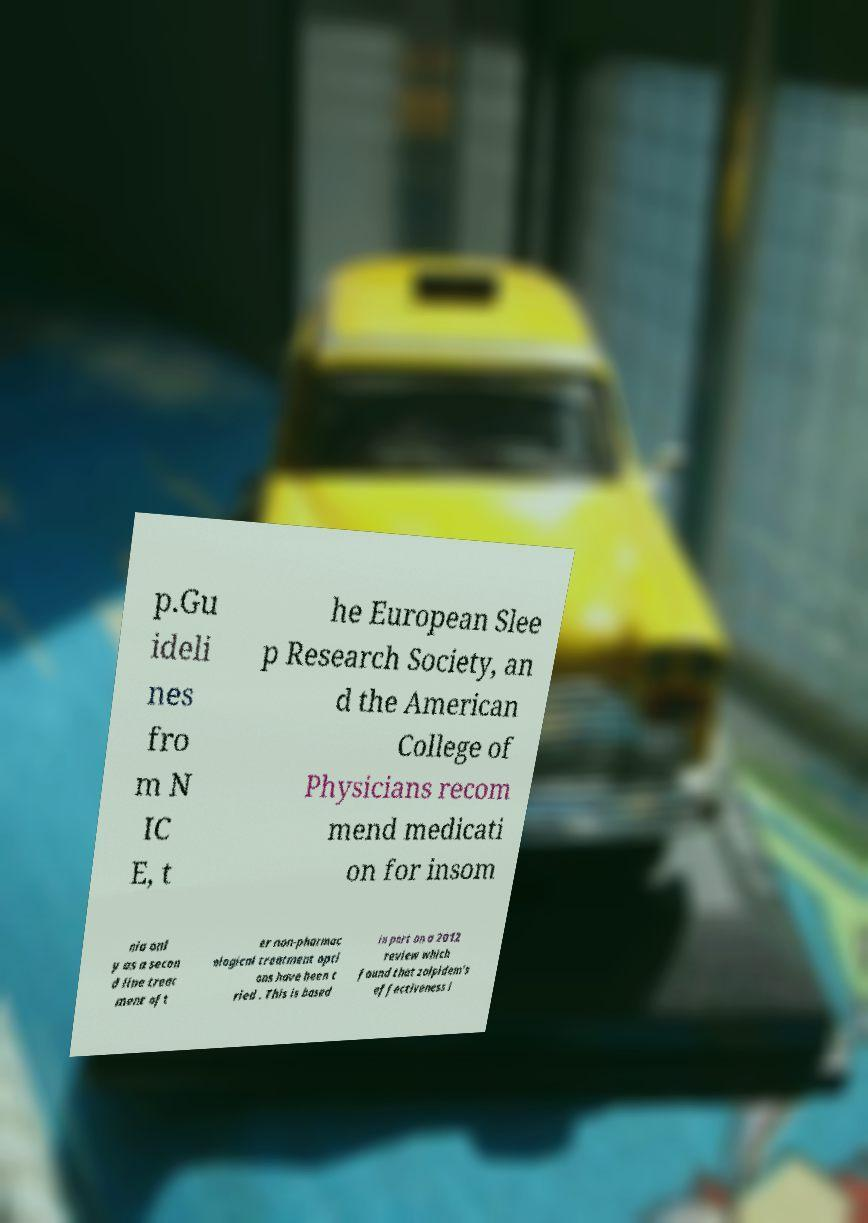Can you read and provide the text displayed in the image?This photo seems to have some interesting text. Can you extract and type it out for me? p.Gu ideli nes fro m N IC E, t he European Slee p Research Society, an d the American College of Physicians recom mend medicati on for insom nia onl y as a secon d line treat ment aft er non-pharmac ological treatment opti ons have been t ried . This is based in part on a 2012 review which found that zolpidem's effectiveness i 